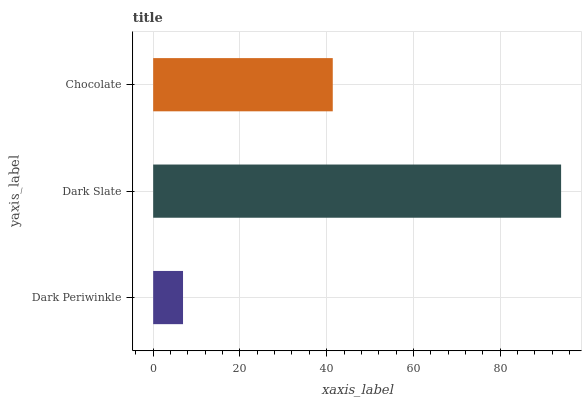Is Dark Periwinkle the minimum?
Answer yes or no. Yes. Is Dark Slate the maximum?
Answer yes or no. Yes. Is Chocolate the minimum?
Answer yes or no. No. Is Chocolate the maximum?
Answer yes or no. No. Is Dark Slate greater than Chocolate?
Answer yes or no. Yes. Is Chocolate less than Dark Slate?
Answer yes or no. Yes. Is Chocolate greater than Dark Slate?
Answer yes or no. No. Is Dark Slate less than Chocolate?
Answer yes or no. No. Is Chocolate the high median?
Answer yes or no. Yes. Is Chocolate the low median?
Answer yes or no. Yes. Is Dark Slate the high median?
Answer yes or no. No. Is Dark Periwinkle the low median?
Answer yes or no. No. 